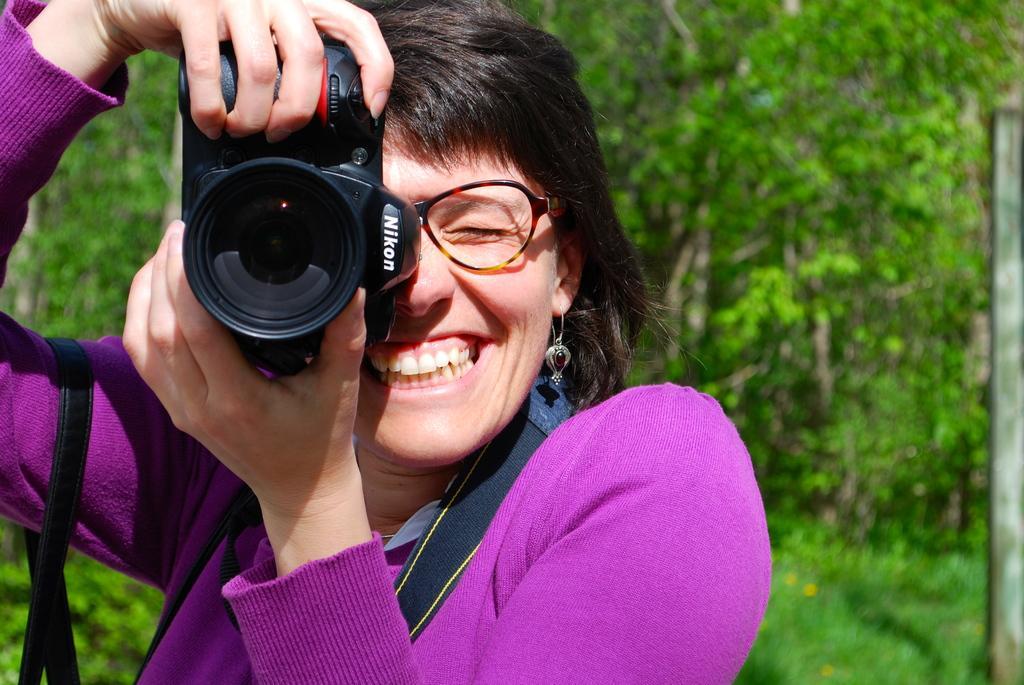How would you summarize this image in a sentence or two? In this picture we can see a woman who is holding a camera with her hands. She is smiling and she has spectacles. On the background we can see some trees. 